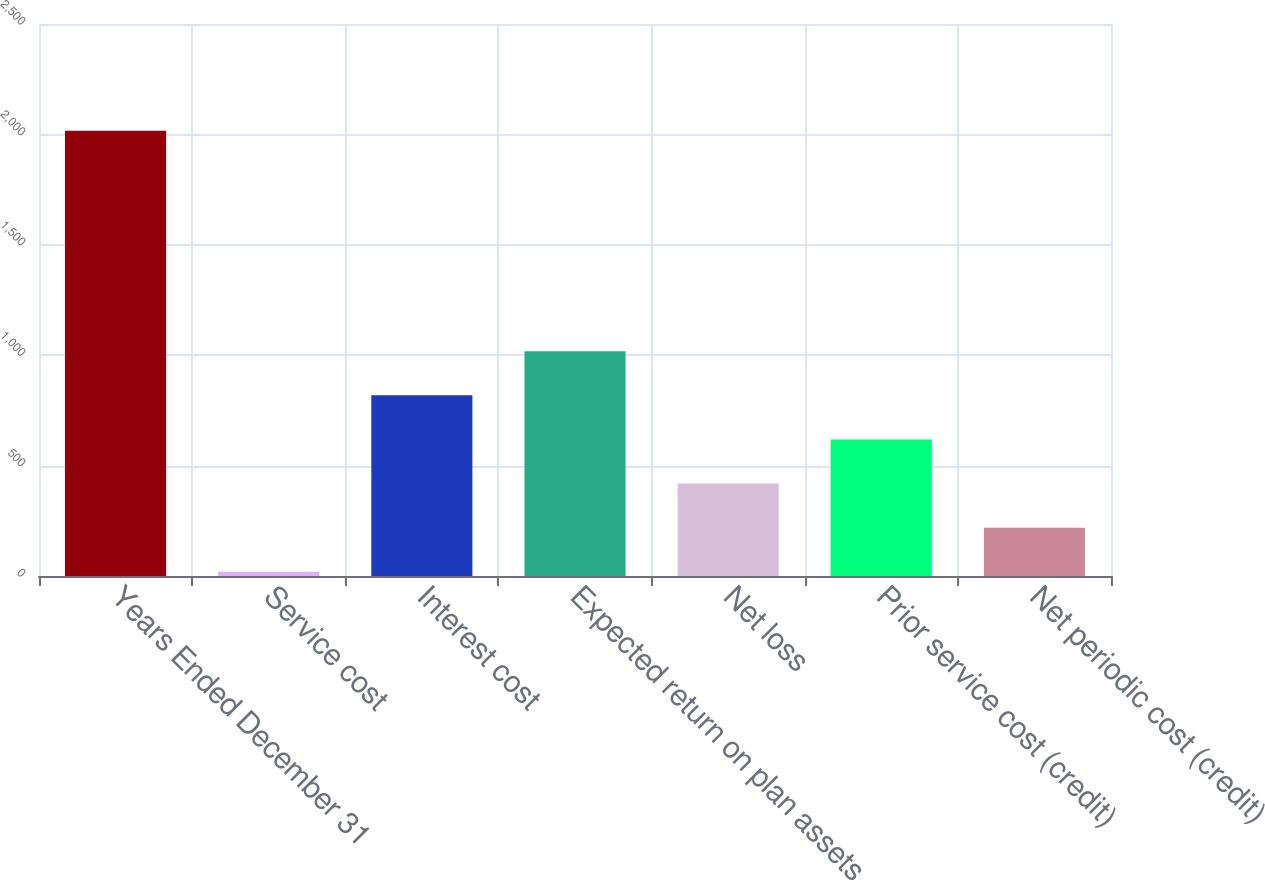Convert chart to OTSL. <chart><loc_0><loc_0><loc_500><loc_500><bar_chart><fcel>Years Ended December 31<fcel>Service cost<fcel>Interest cost<fcel>Expected return on plan assets<fcel>Net loss<fcel>Prior service cost (credit)<fcel>Net periodic cost (credit)<nl><fcel>2017<fcel>19<fcel>818.2<fcel>1018<fcel>418.6<fcel>618.4<fcel>218.8<nl></chart> 